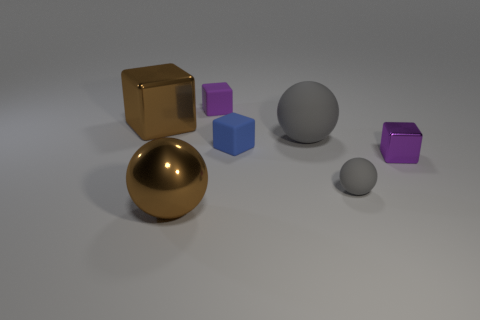If this were part of a larger pattern, what kind of pattern could this be? If these objects were part of a larger pattern, they might form a repeating sequence of geometric shapes and colors, symbolizing the variety found in design or nature. It could be a motif used in a study of geometry or abstract art. 